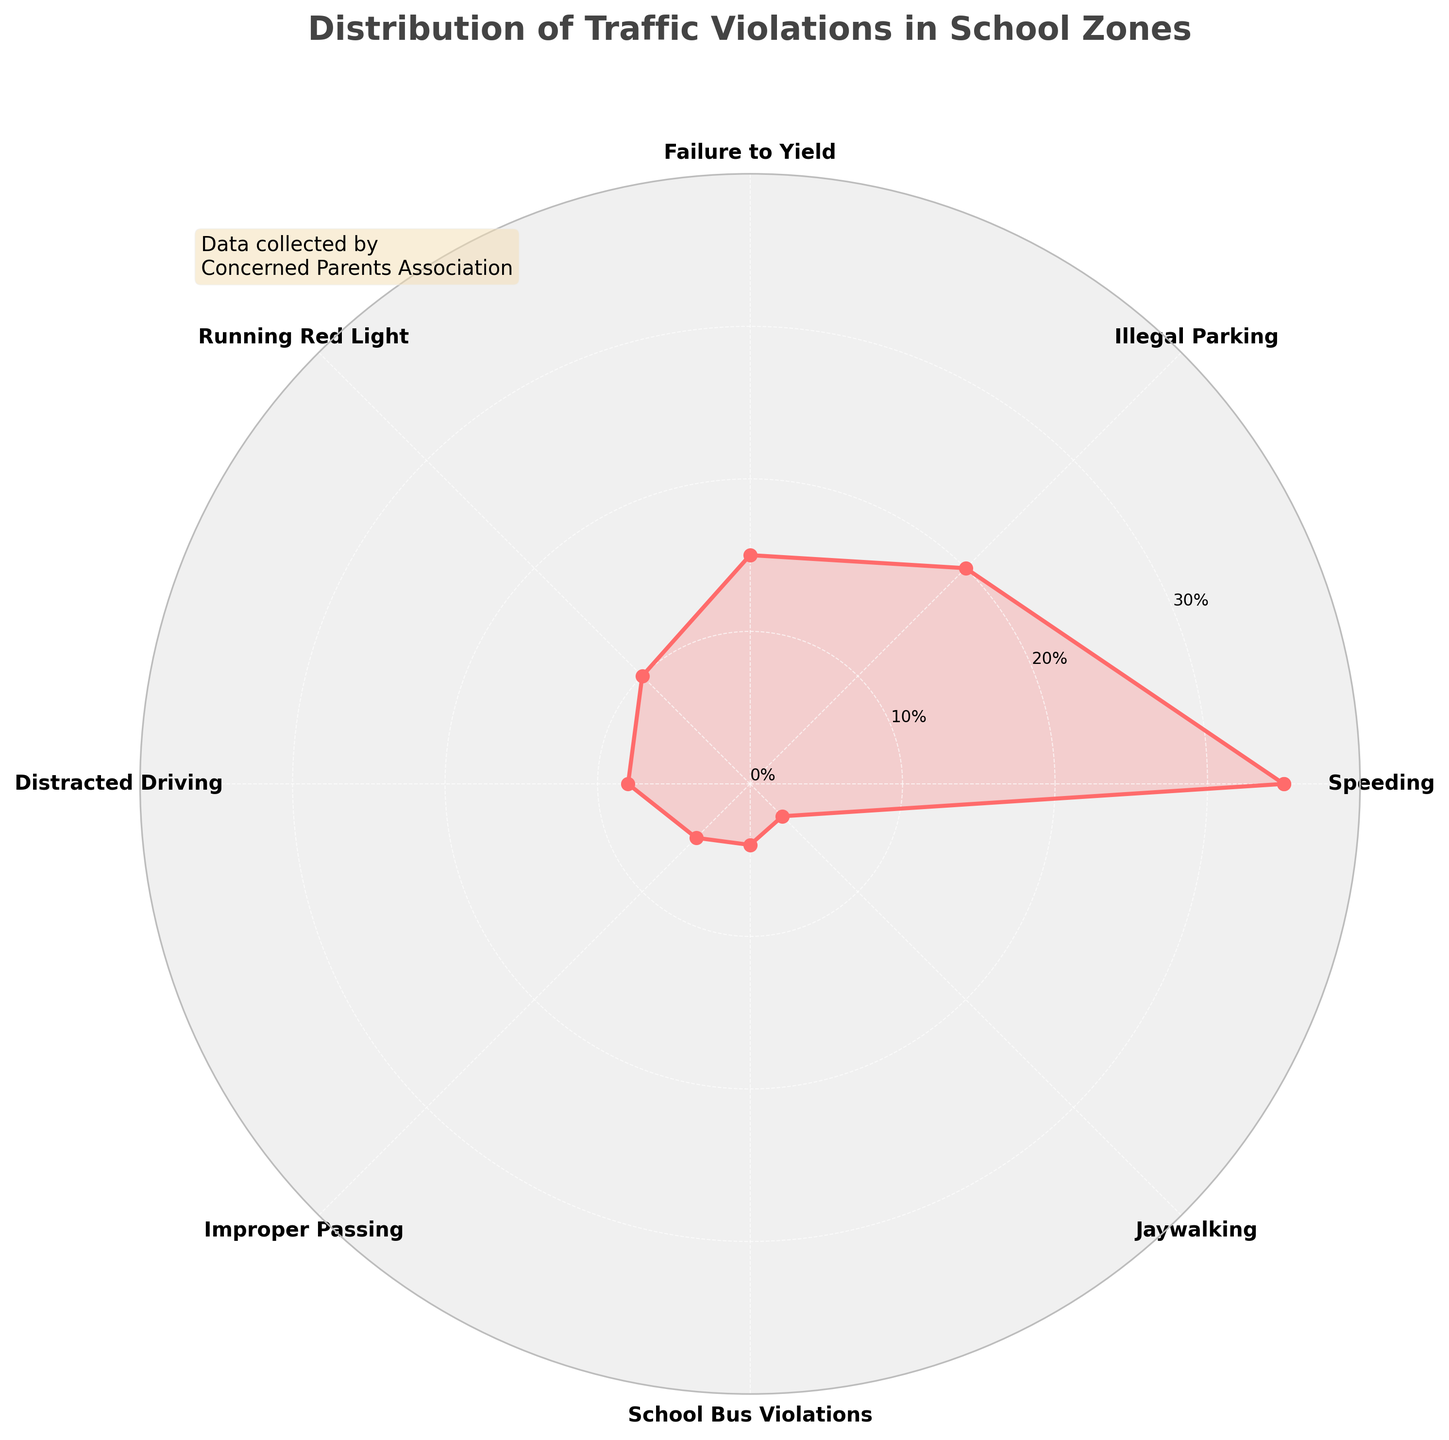What is the title of the figure? The title is usually found at the top of the figure and often describes what the figure is about. The title here reads, "Distribution of Traffic Violations in School Zones."
Answer: Distribution of Traffic Violations in School Zones How many types of traffic violations are shown in the figure? By counting the distinct labels (or categories) on the axes of the polar chart, we can determine the number of types of traffic violations shown.
Answer: 8 Which type of violation has the highest percentage? By looking at the longest section on the polar chart, which represents the largest data point, we can identify that "Speeding" has the highest percentage of 35%.
Answer: Speeding What is the sum of the percentages for Illegal Parking and Running Red Light? To get this sum, we add the percentage values corresponding to Illegal Parking (20%) and Running Red Light (10%). Hence, 20% + 10% = 30%.
Answer: 30% What type of violation has a lower percentage, Distracted Driving or Improper Passing? To determine this, we compare the lengths of the sections for Distracted Driving (8%) and Improper Passing (5%). Distracted Driving has a higher percentage, so Improper Passing has a lower one.
Answer: Improper Passing What is the combined percentage of Speeding, School Bus Violations, and Jaywalking? We add the percentages of Speeding (35%), School Bus Violations (4%), and Jaywalking (3%). Therefore, 35% + 4% + 3% = 42%.
Answer: 42% Which two types of violations have percentages adding up to match Speeding's percentage? To solve this, we find pairs of violation types whose percentages sum to 35%. Illegal Parking (20%) and Failure to Yield (15%) together add up to 35%.
Answer: Illegal Parking and Failure to Yield How does the percentage of Speeding compare to the percentage of Illegal Parking? Is it greater, less, or equal? Speeding is 35% and Illegal Parking is 20%. Since 35% is greater than 20%, Speeding has a higher percentage.
Answer: Greater What is the average percentage of all the violation types shown in the figure? Summing all percentages (35 + 20 + 15 + 10 + 8 + 5 + 4 + 3 = 100) and dividing by the number of types (8), we get the average: 100% / 8 = 12.5%.
Answer: 12.5% What proportion of traffic violations are school bus related? The percentage of School Bus Violations is 4%. As a proportion of the total 100%, it is 4/100 = 0.04 or 4%.
Answer: 4% 